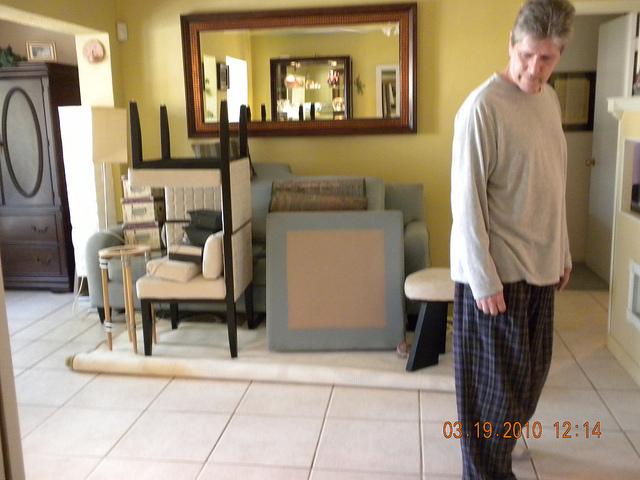Does the man have on dress pants?
Keep it brief. No. What color is the chair?
Quick response, please. Beige. What kind of floor is the man standing on?
Quick response, please. Tile. 